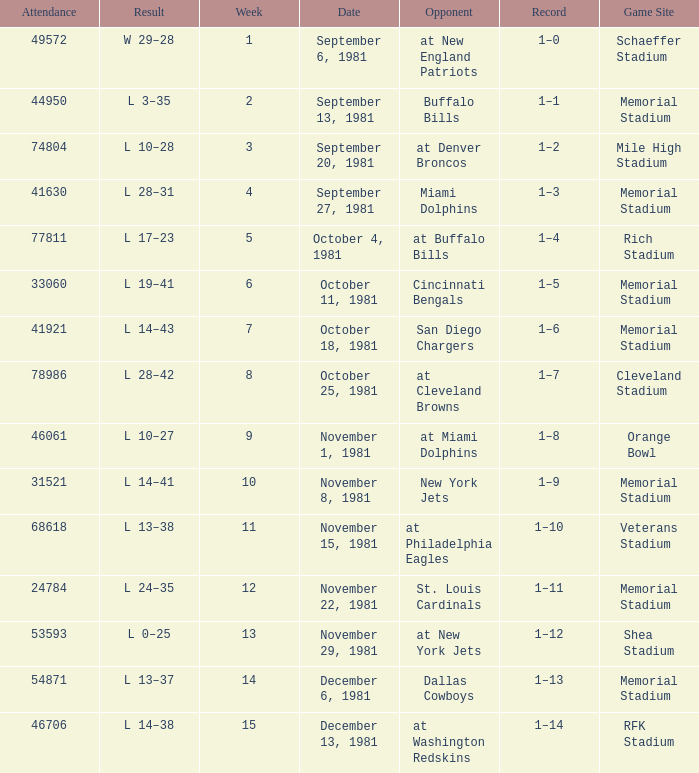When it is October 25, 1981 who is the opponent? At cleveland browns. 